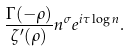<formula> <loc_0><loc_0><loc_500><loc_500>\frac { \Gamma ( - \rho ) } { \zeta ^ { \prime } ( \rho ) } n ^ { \sigma } e ^ { i \tau \log n } .</formula> 